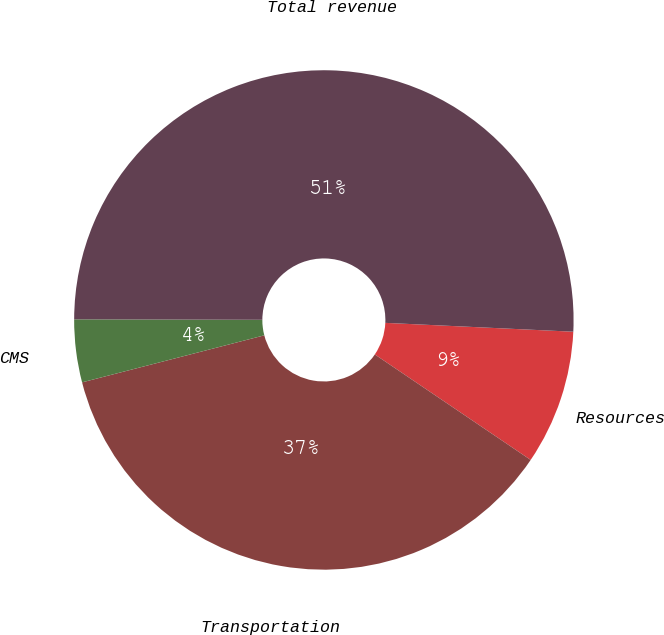Convert chart. <chart><loc_0><loc_0><loc_500><loc_500><pie_chart><fcel>Resources<fcel>Transportation<fcel>CMS<fcel>Total revenue<nl><fcel>8.72%<fcel>36.51%<fcel>4.06%<fcel>50.71%<nl></chart> 